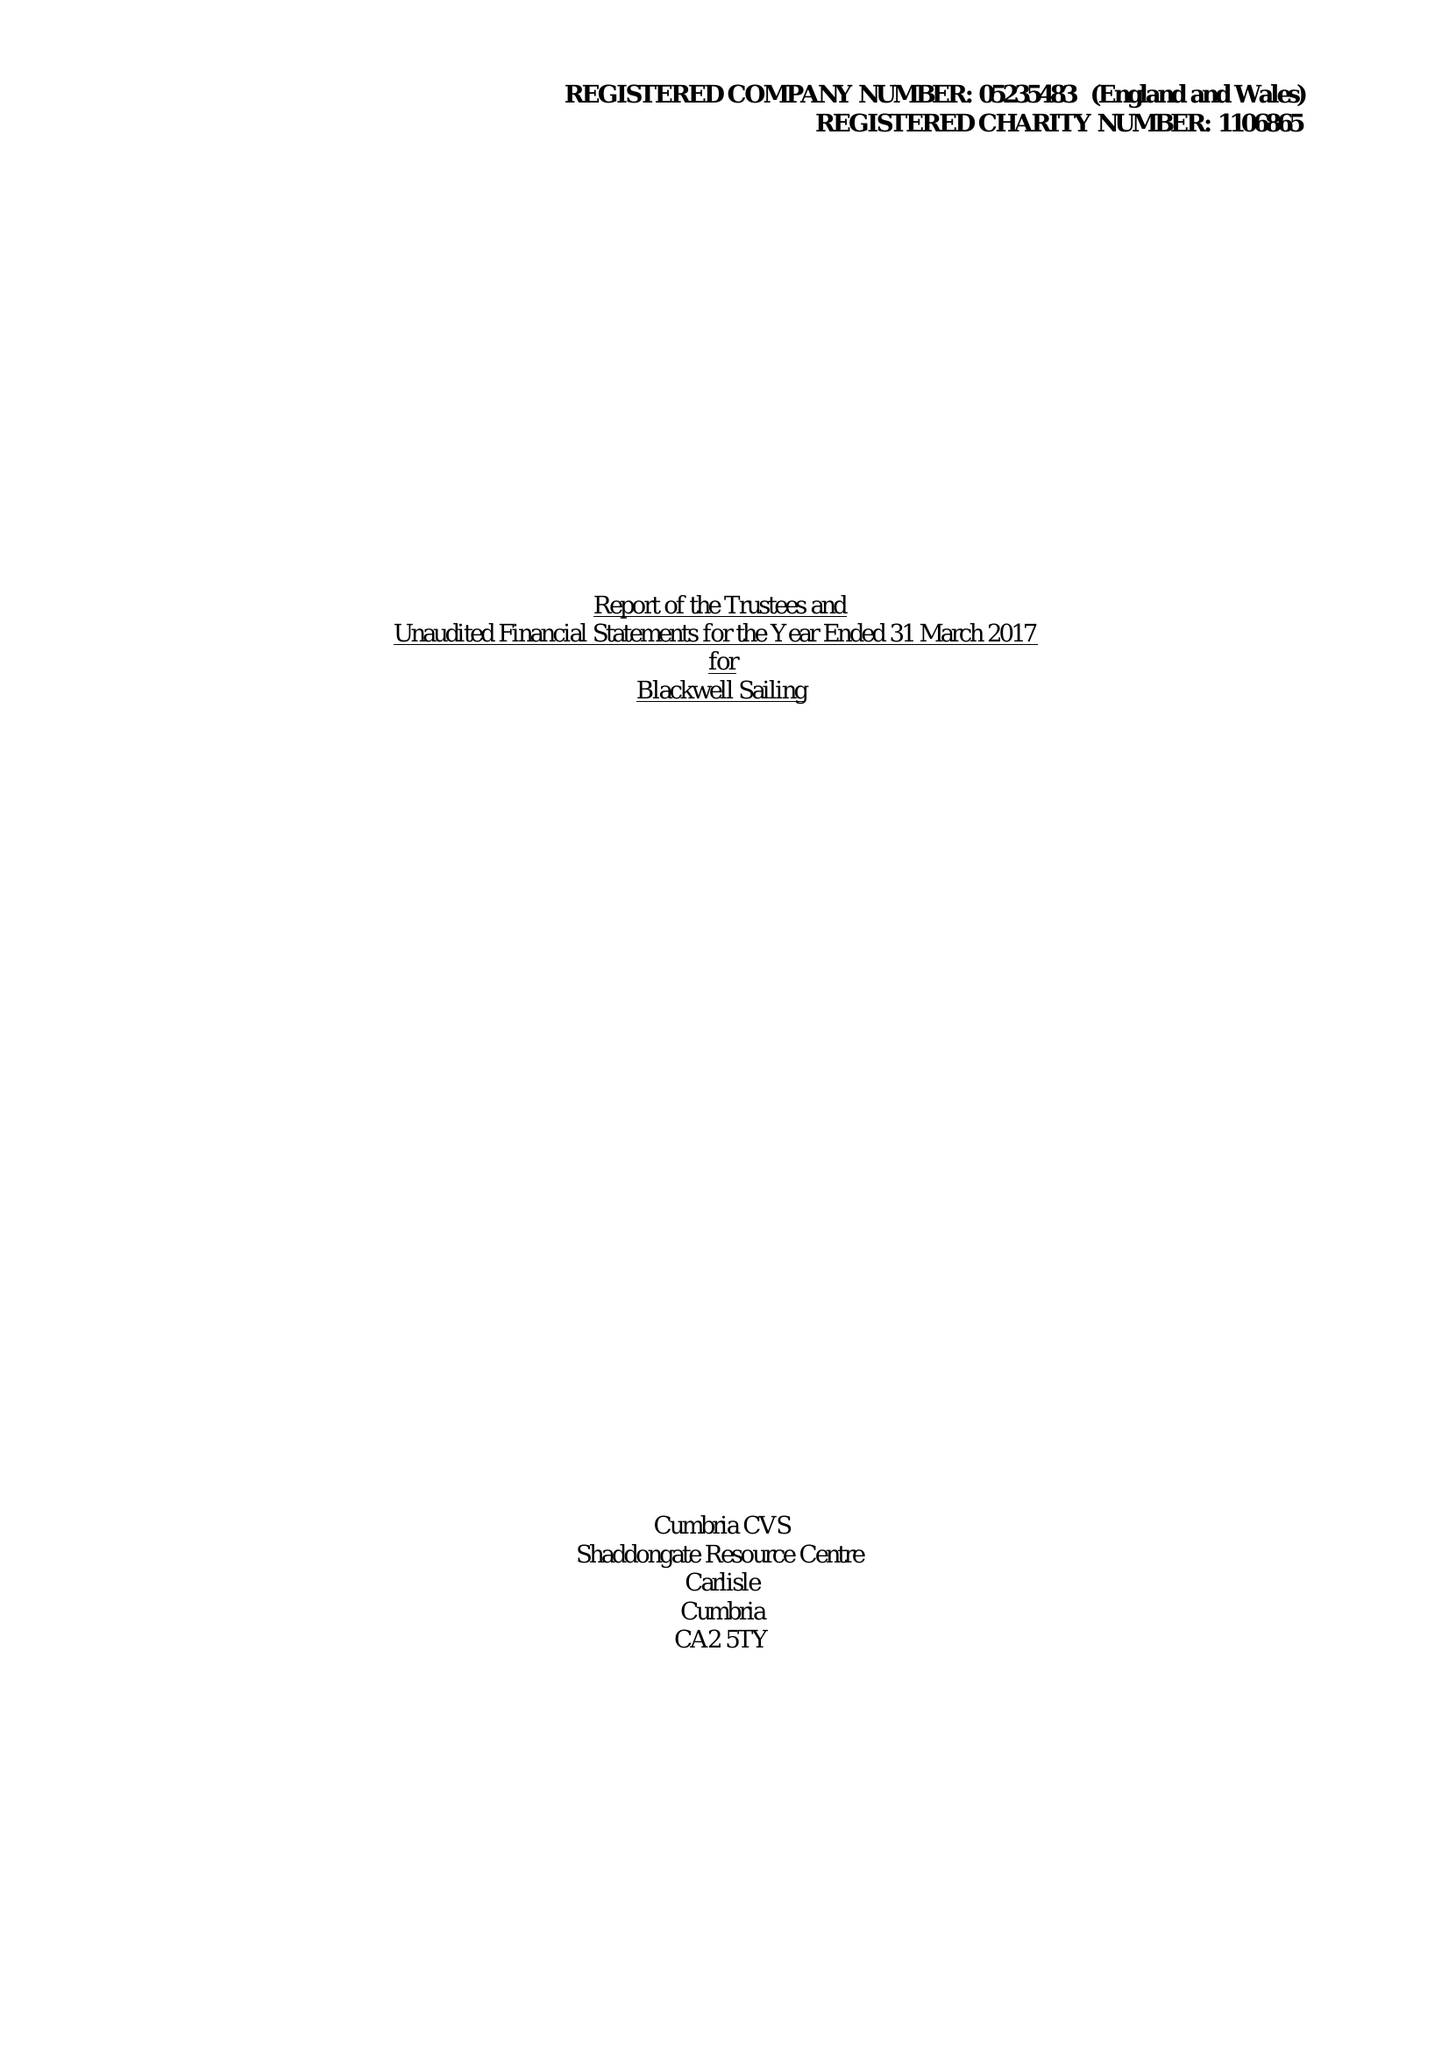What is the value for the address__postcode?
Answer the question using a single word or phrase. LA23 3HE 